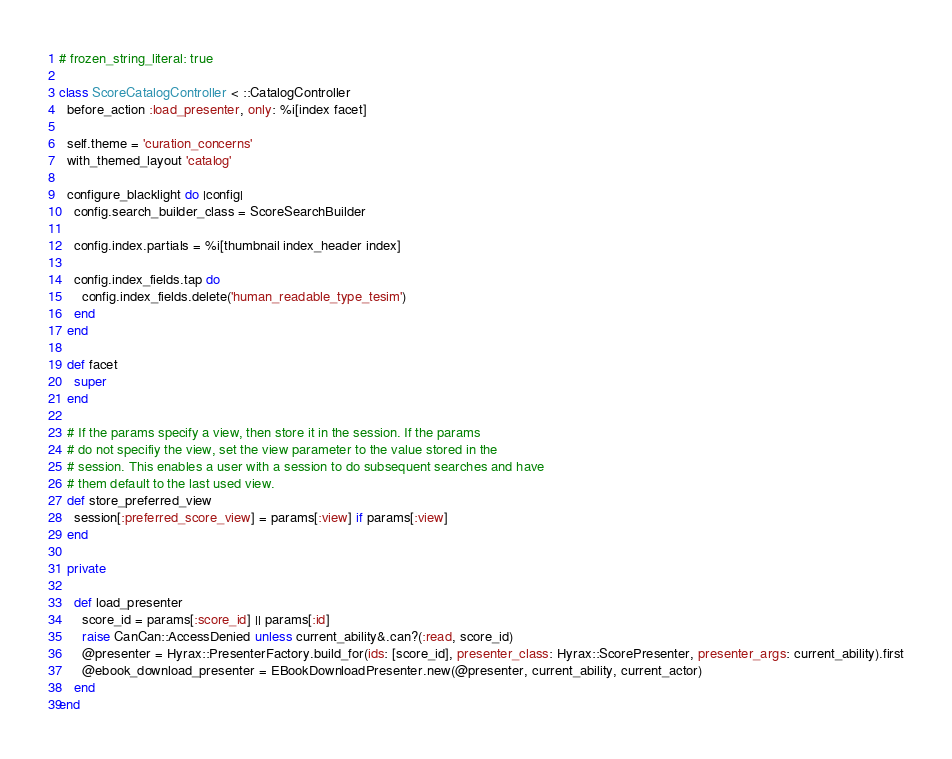Convert code to text. <code><loc_0><loc_0><loc_500><loc_500><_Ruby_># frozen_string_literal: true

class ScoreCatalogController < ::CatalogController
  before_action :load_presenter, only: %i[index facet]

  self.theme = 'curation_concerns'
  with_themed_layout 'catalog'

  configure_blacklight do |config|
    config.search_builder_class = ScoreSearchBuilder

    config.index.partials = %i[thumbnail index_header index]

    config.index_fields.tap do
      config.index_fields.delete('human_readable_type_tesim')
    end
  end

  def facet
    super
  end

  # If the params specify a view, then store it in the session. If the params
  # do not specifiy the view, set the view parameter to the value stored in the
  # session. This enables a user with a session to do subsequent searches and have
  # them default to the last used view.
  def store_preferred_view
    session[:preferred_score_view] = params[:view] if params[:view]
  end

  private

    def load_presenter
      score_id = params[:score_id] || params[:id]
      raise CanCan::AccessDenied unless current_ability&.can?(:read, score_id)
      @presenter = Hyrax::PresenterFactory.build_for(ids: [score_id], presenter_class: Hyrax::ScorePresenter, presenter_args: current_ability).first
      @ebook_download_presenter = EBookDownloadPresenter.new(@presenter, current_ability, current_actor)
    end
end
</code> 